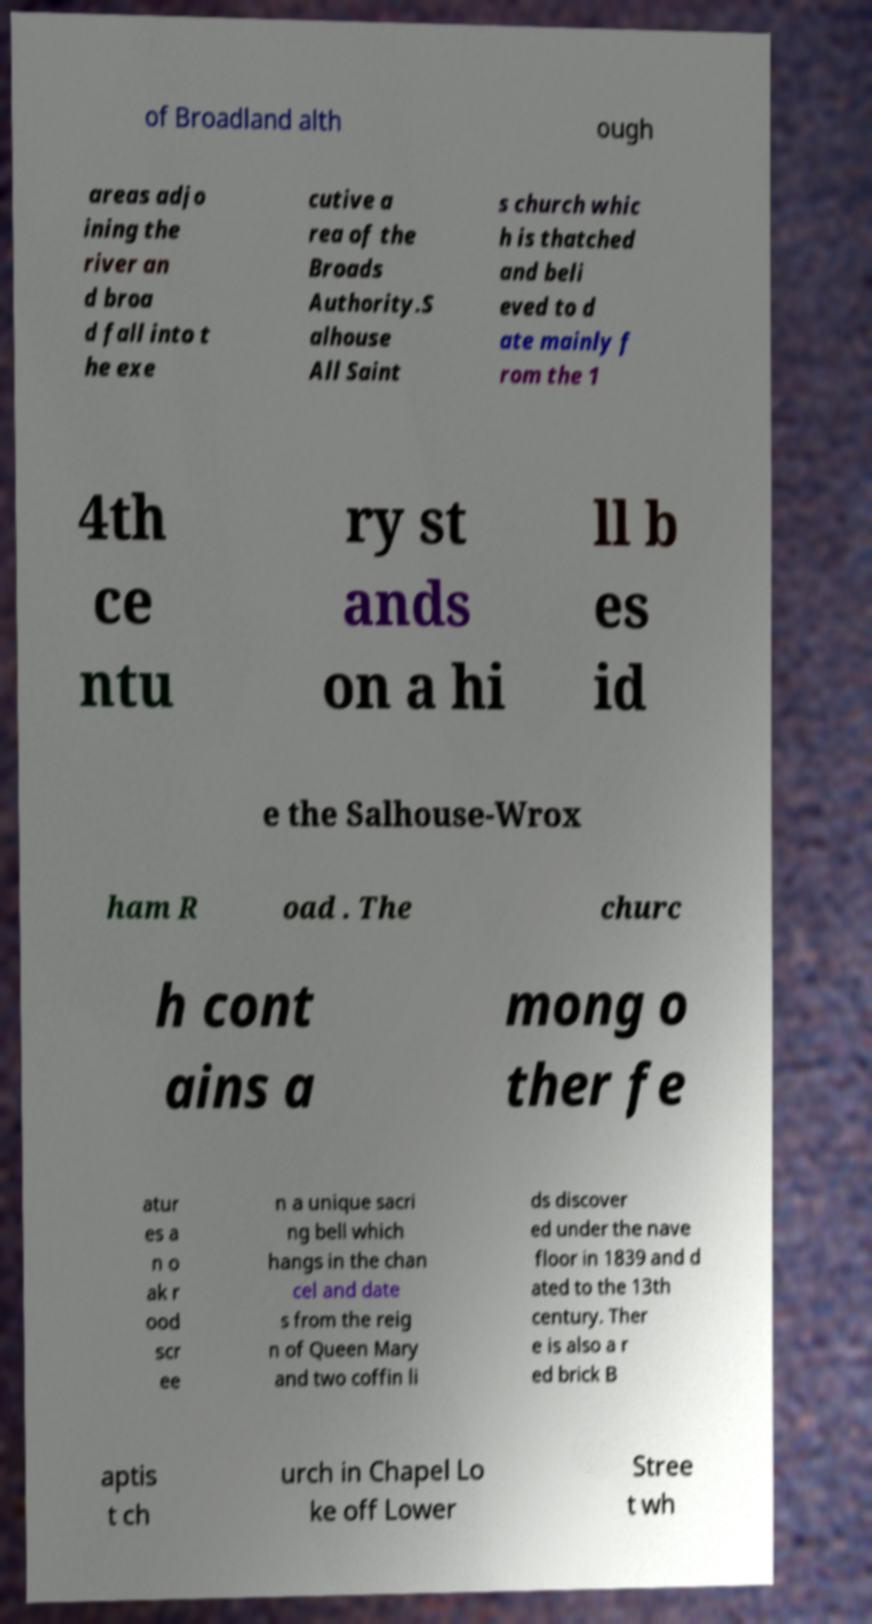What messages or text are displayed in this image? I need them in a readable, typed format. of Broadland alth ough areas adjo ining the river an d broa d fall into t he exe cutive a rea of the Broads Authority.S alhouse All Saint s church whic h is thatched and beli eved to d ate mainly f rom the 1 4th ce ntu ry st ands on a hi ll b es id e the Salhouse-Wrox ham R oad . The churc h cont ains a mong o ther fe atur es a n o ak r ood scr ee n a unique sacri ng bell which hangs in the chan cel and date s from the reig n of Queen Mary and two coffin li ds discover ed under the nave floor in 1839 and d ated to the 13th century. Ther e is also a r ed brick B aptis t ch urch in Chapel Lo ke off Lower Stree t wh 